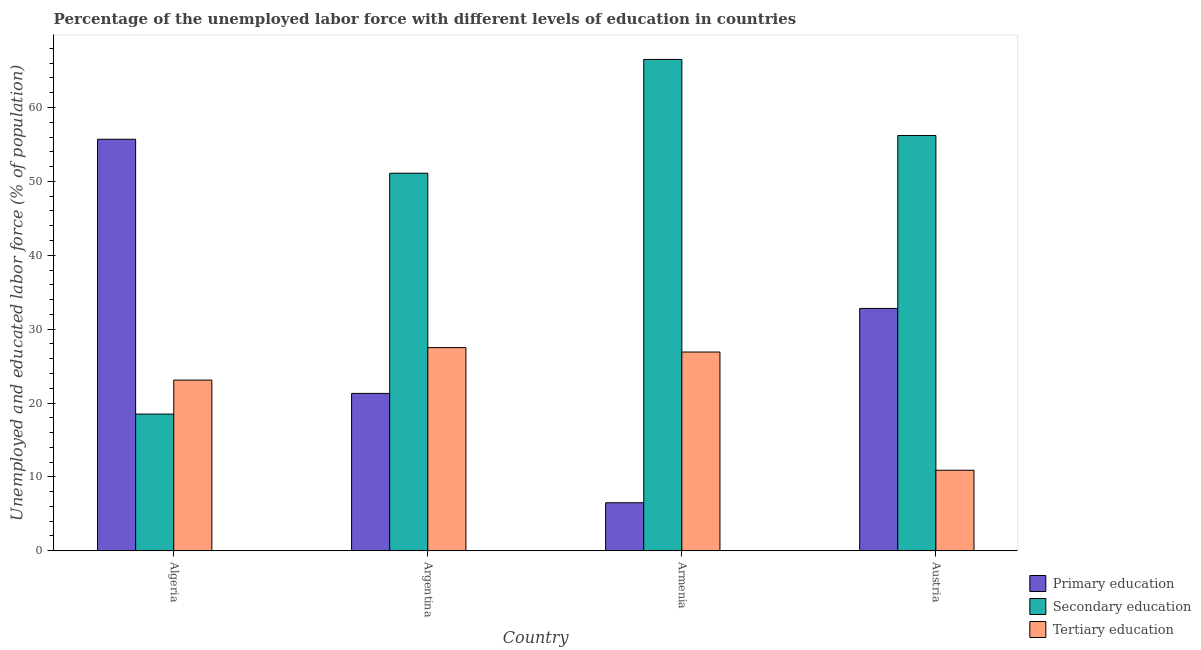How many groups of bars are there?
Offer a very short reply. 4. How many bars are there on the 4th tick from the left?
Keep it short and to the point. 3. How many bars are there on the 3rd tick from the right?
Offer a terse response. 3. What is the label of the 2nd group of bars from the left?
Give a very brief answer. Argentina. In how many cases, is the number of bars for a given country not equal to the number of legend labels?
Provide a succinct answer. 0. What is the percentage of labor force who received primary education in Algeria?
Ensure brevity in your answer.  55.7. Across all countries, what is the maximum percentage of labor force who received secondary education?
Ensure brevity in your answer.  66.5. Across all countries, what is the minimum percentage of labor force who received tertiary education?
Your response must be concise. 10.9. In which country was the percentage of labor force who received primary education maximum?
Offer a very short reply. Algeria. In which country was the percentage of labor force who received primary education minimum?
Keep it short and to the point. Armenia. What is the total percentage of labor force who received primary education in the graph?
Provide a short and direct response. 116.3. What is the difference between the percentage of labor force who received tertiary education in Armenia and that in Austria?
Offer a terse response. 16. What is the difference between the percentage of labor force who received secondary education in Armenia and the percentage of labor force who received primary education in Austria?
Your answer should be very brief. 33.7. What is the average percentage of labor force who received primary education per country?
Your answer should be very brief. 29.07. What is the difference between the percentage of labor force who received primary education and percentage of labor force who received secondary education in Austria?
Offer a terse response. -23.4. In how many countries, is the percentage of labor force who received tertiary education greater than 48 %?
Your answer should be very brief. 0. What is the ratio of the percentage of labor force who received primary education in Armenia to that in Austria?
Keep it short and to the point. 0.2. Is the percentage of labor force who received tertiary education in Armenia less than that in Austria?
Give a very brief answer. No. Is the difference between the percentage of labor force who received tertiary education in Algeria and Austria greater than the difference between the percentage of labor force who received primary education in Algeria and Austria?
Give a very brief answer. No. What is the difference between the highest and the second highest percentage of labor force who received primary education?
Your response must be concise. 22.9. What is the difference between the highest and the lowest percentage of labor force who received primary education?
Keep it short and to the point. 49.2. Is the sum of the percentage of labor force who received tertiary education in Argentina and Armenia greater than the maximum percentage of labor force who received primary education across all countries?
Give a very brief answer. No. What does the 3rd bar from the right in Algeria represents?
Your answer should be compact. Primary education. Are all the bars in the graph horizontal?
Ensure brevity in your answer.  No. How many countries are there in the graph?
Offer a very short reply. 4. Are the values on the major ticks of Y-axis written in scientific E-notation?
Keep it short and to the point. No. Does the graph contain grids?
Your answer should be very brief. No. Where does the legend appear in the graph?
Offer a terse response. Bottom right. How are the legend labels stacked?
Provide a short and direct response. Vertical. What is the title of the graph?
Your answer should be very brief. Percentage of the unemployed labor force with different levels of education in countries. Does "Nuclear sources" appear as one of the legend labels in the graph?
Your answer should be very brief. No. What is the label or title of the X-axis?
Your answer should be compact. Country. What is the label or title of the Y-axis?
Give a very brief answer. Unemployed and educated labor force (% of population). What is the Unemployed and educated labor force (% of population) of Primary education in Algeria?
Ensure brevity in your answer.  55.7. What is the Unemployed and educated labor force (% of population) of Secondary education in Algeria?
Your response must be concise. 18.5. What is the Unemployed and educated labor force (% of population) of Tertiary education in Algeria?
Keep it short and to the point. 23.1. What is the Unemployed and educated labor force (% of population) of Primary education in Argentina?
Provide a short and direct response. 21.3. What is the Unemployed and educated labor force (% of population) in Secondary education in Argentina?
Keep it short and to the point. 51.1. What is the Unemployed and educated labor force (% of population) in Tertiary education in Argentina?
Your answer should be very brief. 27.5. What is the Unemployed and educated labor force (% of population) in Primary education in Armenia?
Keep it short and to the point. 6.5. What is the Unemployed and educated labor force (% of population) in Secondary education in Armenia?
Your response must be concise. 66.5. What is the Unemployed and educated labor force (% of population) in Tertiary education in Armenia?
Your response must be concise. 26.9. What is the Unemployed and educated labor force (% of population) in Primary education in Austria?
Keep it short and to the point. 32.8. What is the Unemployed and educated labor force (% of population) of Secondary education in Austria?
Offer a very short reply. 56.2. What is the Unemployed and educated labor force (% of population) of Tertiary education in Austria?
Your answer should be very brief. 10.9. Across all countries, what is the maximum Unemployed and educated labor force (% of population) of Primary education?
Provide a short and direct response. 55.7. Across all countries, what is the maximum Unemployed and educated labor force (% of population) in Secondary education?
Your answer should be compact. 66.5. Across all countries, what is the minimum Unemployed and educated labor force (% of population) of Primary education?
Your answer should be very brief. 6.5. Across all countries, what is the minimum Unemployed and educated labor force (% of population) of Tertiary education?
Offer a very short reply. 10.9. What is the total Unemployed and educated labor force (% of population) of Primary education in the graph?
Offer a very short reply. 116.3. What is the total Unemployed and educated labor force (% of population) of Secondary education in the graph?
Offer a very short reply. 192.3. What is the total Unemployed and educated labor force (% of population) in Tertiary education in the graph?
Ensure brevity in your answer.  88.4. What is the difference between the Unemployed and educated labor force (% of population) in Primary education in Algeria and that in Argentina?
Offer a terse response. 34.4. What is the difference between the Unemployed and educated labor force (% of population) of Secondary education in Algeria and that in Argentina?
Your answer should be compact. -32.6. What is the difference between the Unemployed and educated labor force (% of population) of Primary education in Algeria and that in Armenia?
Provide a succinct answer. 49.2. What is the difference between the Unemployed and educated labor force (% of population) of Secondary education in Algeria and that in Armenia?
Your answer should be very brief. -48. What is the difference between the Unemployed and educated labor force (% of population) in Primary education in Algeria and that in Austria?
Provide a succinct answer. 22.9. What is the difference between the Unemployed and educated labor force (% of population) of Secondary education in Algeria and that in Austria?
Provide a succinct answer. -37.7. What is the difference between the Unemployed and educated labor force (% of population) in Tertiary education in Algeria and that in Austria?
Offer a very short reply. 12.2. What is the difference between the Unemployed and educated labor force (% of population) of Primary education in Argentina and that in Armenia?
Your answer should be compact. 14.8. What is the difference between the Unemployed and educated labor force (% of population) in Secondary education in Argentina and that in Armenia?
Offer a very short reply. -15.4. What is the difference between the Unemployed and educated labor force (% of population) of Primary education in Argentina and that in Austria?
Your answer should be very brief. -11.5. What is the difference between the Unemployed and educated labor force (% of population) in Primary education in Armenia and that in Austria?
Provide a short and direct response. -26.3. What is the difference between the Unemployed and educated labor force (% of population) in Tertiary education in Armenia and that in Austria?
Provide a short and direct response. 16. What is the difference between the Unemployed and educated labor force (% of population) in Primary education in Algeria and the Unemployed and educated labor force (% of population) in Secondary education in Argentina?
Offer a very short reply. 4.6. What is the difference between the Unemployed and educated labor force (% of population) of Primary education in Algeria and the Unemployed and educated labor force (% of population) of Tertiary education in Argentina?
Your answer should be compact. 28.2. What is the difference between the Unemployed and educated labor force (% of population) in Primary education in Algeria and the Unemployed and educated labor force (% of population) in Tertiary education in Armenia?
Ensure brevity in your answer.  28.8. What is the difference between the Unemployed and educated labor force (% of population) of Primary education in Algeria and the Unemployed and educated labor force (% of population) of Secondary education in Austria?
Your answer should be compact. -0.5. What is the difference between the Unemployed and educated labor force (% of population) in Primary education in Algeria and the Unemployed and educated labor force (% of population) in Tertiary education in Austria?
Offer a very short reply. 44.8. What is the difference between the Unemployed and educated labor force (% of population) in Secondary education in Algeria and the Unemployed and educated labor force (% of population) in Tertiary education in Austria?
Your answer should be very brief. 7.6. What is the difference between the Unemployed and educated labor force (% of population) of Primary education in Argentina and the Unemployed and educated labor force (% of population) of Secondary education in Armenia?
Provide a succinct answer. -45.2. What is the difference between the Unemployed and educated labor force (% of population) in Primary education in Argentina and the Unemployed and educated labor force (% of population) in Tertiary education in Armenia?
Give a very brief answer. -5.6. What is the difference between the Unemployed and educated labor force (% of population) of Secondary education in Argentina and the Unemployed and educated labor force (% of population) of Tertiary education in Armenia?
Offer a terse response. 24.2. What is the difference between the Unemployed and educated labor force (% of population) of Primary education in Argentina and the Unemployed and educated labor force (% of population) of Secondary education in Austria?
Your answer should be very brief. -34.9. What is the difference between the Unemployed and educated labor force (% of population) of Primary education in Argentina and the Unemployed and educated labor force (% of population) of Tertiary education in Austria?
Ensure brevity in your answer.  10.4. What is the difference between the Unemployed and educated labor force (% of population) in Secondary education in Argentina and the Unemployed and educated labor force (% of population) in Tertiary education in Austria?
Provide a succinct answer. 40.2. What is the difference between the Unemployed and educated labor force (% of population) in Primary education in Armenia and the Unemployed and educated labor force (% of population) in Secondary education in Austria?
Your answer should be very brief. -49.7. What is the difference between the Unemployed and educated labor force (% of population) of Secondary education in Armenia and the Unemployed and educated labor force (% of population) of Tertiary education in Austria?
Keep it short and to the point. 55.6. What is the average Unemployed and educated labor force (% of population) in Primary education per country?
Make the answer very short. 29.07. What is the average Unemployed and educated labor force (% of population) of Secondary education per country?
Keep it short and to the point. 48.08. What is the average Unemployed and educated labor force (% of population) of Tertiary education per country?
Your response must be concise. 22.1. What is the difference between the Unemployed and educated labor force (% of population) in Primary education and Unemployed and educated labor force (% of population) in Secondary education in Algeria?
Keep it short and to the point. 37.2. What is the difference between the Unemployed and educated labor force (% of population) in Primary education and Unemployed and educated labor force (% of population) in Tertiary education in Algeria?
Provide a succinct answer. 32.6. What is the difference between the Unemployed and educated labor force (% of population) in Primary education and Unemployed and educated labor force (% of population) in Secondary education in Argentina?
Offer a terse response. -29.8. What is the difference between the Unemployed and educated labor force (% of population) in Secondary education and Unemployed and educated labor force (% of population) in Tertiary education in Argentina?
Provide a succinct answer. 23.6. What is the difference between the Unemployed and educated labor force (% of population) of Primary education and Unemployed and educated labor force (% of population) of Secondary education in Armenia?
Keep it short and to the point. -60. What is the difference between the Unemployed and educated labor force (% of population) of Primary education and Unemployed and educated labor force (% of population) of Tertiary education in Armenia?
Ensure brevity in your answer.  -20.4. What is the difference between the Unemployed and educated labor force (% of population) in Secondary education and Unemployed and educated labor force (% of population) in Tertiary education in Armenia?
Offer a terse response. 39.6. What is the difference between the Unemployed and educated labor force (% of population) of Primary education and Unemployed and educated labor force (% of population) of Secondary education in Austria?
Provide a short and direct response. -23.4. What is the difference between the Unemployed and educated labor force (% of population) in Primary education and Unemployed and educated labor force (% of population) in Tertiary education in Austria?
Your response must be concise. 21.9. What is the difference between the Unemployed and educated labor force (% of population) of Secondary education and Unemployed and educated labor force (% of population) of Tertiary education in Austria?
Your answer should be very brief. 45.3. What is the ratio of the Unemployed and educated labor force (% of population) of Primary education in Algeria to that in Argentina?
Ensure brevity in your answer.  2.62. What is the ratio of the Unemployed and educated labor force (% of population) in Secondary education in Algeria to that in Argentina?
Provide a short and direct response. 0.36. What is the ratio of the Unemployed and educated labor force (% of population) of Tertiary education in Algeria to that in Argentina?
Make the answer very short. 0.84. What is the ratio of the Unemployed and educated labor force (% of population) in Primary education in Algeria to that in Armenia?
Your answer should be compact. 8.57. What is the ratio of the Unemployed and educated labor force (% of population) of Secondary education in Algeria to that in Armenia?
Provide a succinct answer. 0.28. What is the ratio of the Unemployed and educated labor force (% of population) of Tertiary education in Algeria to that in Armenia?
Offer a very short reply. 0.86. What is the ratio of the Unemployed and educated labor force (% of population) in Primary education in Algeria to that in Austria?
Give a very brief answer. 1.7. What is the ratio of the Unemployed and educated labor force (% of population) of Secondary education in Algeria to that in Austria?
Offer a very short reply. 0.33. What is the ratio of the Unemployed and educated labor force (% of population) of Tertiary education in Algeria to that in Austria?
Ensure brevity in your answer.  2.12. What is the ratio of the Unemployed and educated labor force (% of population) of Primary education in Argentina to that in Armenia?
Ensure brevity in your answer.  3.28. What is the ratio of the Unemployed and educated labor force (% of population) in Secondary education in Argentina to that in Armenia?
Make the answer very short. 0.77. What is the ratio of the Unemployed and educated labor force (% of population) in Tertiary education in Argentina to that in Armenia?
Provide a succinct answer. 1.02. What is the ratio of the Unemployed and educated labor force (% of population) in Primary education in Argentina to that in Austria?
Your answer should be very brief. 0.65. What is the ratio of the Unemployed and educated labor force (% of population) in Secondary education in Argentina to that in Austria?
Make the answer very short. 0.91. What is the ratio of the Unemployed and educated labor force (% of population) of Tertiary education in Argentina to that in Austria?
Offer a terse response. 2.52. What is the ratio of the Unemployed and educated labor force (% of population) of Primary education in Armenia to that in Austria?
Keep it short and to the point. 0.2. What is the ratio of the Unemployed and educated labor force (% of population) in Secondary education in Armenia to that in Austria?
Provide a succinct answer. 1.18. What is the ratio of the Unemployed and educated labor force (% of population) in Tertiary education in Armenia to that in Austria?
Make the answer very short. 2.47. What is the difference between the highest and the second highest Unemployed and educated labor force (% of population) of Primary education?
Your answer should be compact. 22.9. What is the difference between the highest and the lowest Unemployed and educated labor force (% of population) in Primary education?
Your response must be concise. 49.2. What is the difference between the highest and the lowest Unemployed and educated labor force (% of population) of Tertiary education?
Keep it short and to the point. 16.6. 